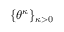Convert formula to latex. <formula><loc_0><loc_0><loc_500><loc_500>\{ \theta ^ { \kappa } \} _ { \kappa > 0 }</formula> 